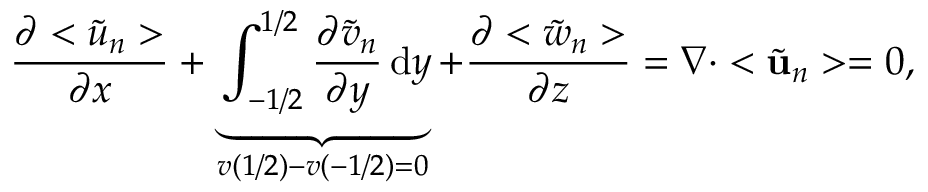Convert formula to latex. <formula><loc_0><loc_0><loc_500><loc_500>\frac { \partial < \tilde { u } _ { n } > } { \partial x } + \underbrace { \int _ { - 1 / 2 } ^ { 1 / 2 } \frac { \partial \tilde { v } _ { n } } { \partial y } \, d y } _ { v \left ( 1 / 2 \right ) - v \left ( - 1 / 2 \right ) = 0 } + \frac { \partial < \tilde { w } _ { n } > } { \partial z } = \nabla \cdot < \tilde { u } _ { n } > = 0 ,</formula> 